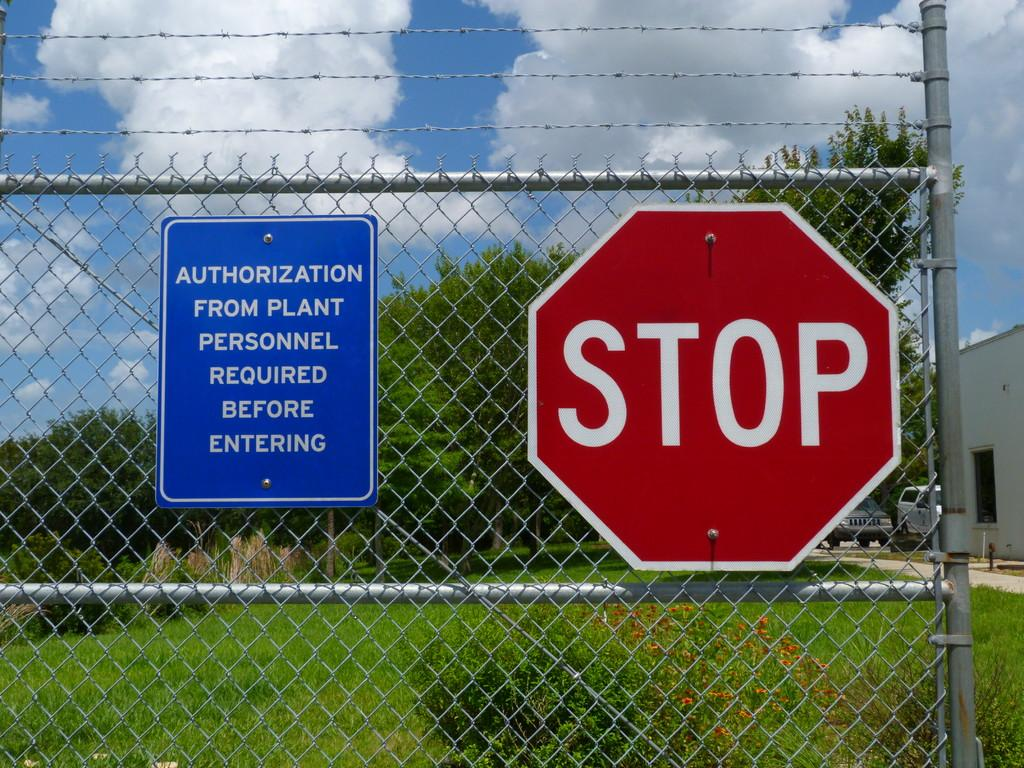<image>
Create a compact narrative representing the image presented. A blue sign next to a stop sign explains that visitors need authorization from personnel. 